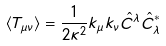Convert formula to latex. <formula><loc_0><loc_0><loc_500><loc_500>\langle T _ { \mu \nu } \rangle = \frac { 1 } { 2 \kappa ^ { 2 } } k _ { \mu } k _ { \nu } \hat { C } ^ { \lambda } \hat { C } _ { \lambda } ^ { * }</formula> 